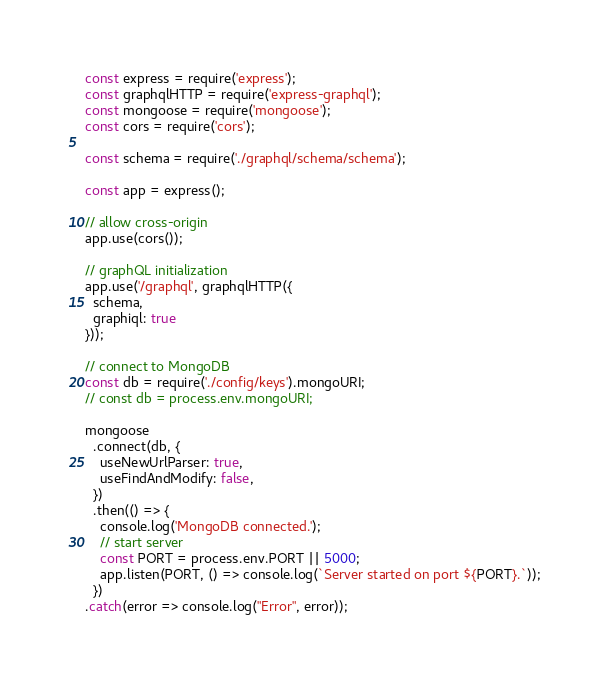<code> <loc_0><loc_0><loc_500><loc_500><_JavaScript_>const express = require('express');
const graphqlHTTP = require('express-graphql');
const mongoose = require('mongoose');
const cors = require('cors');

const schema = require('./graphql/schema/schema');

const app = express();

// allow cross-origin
app.use(cors());

// graphQL initialization
app.use('/graphql', graphqlHTTP({
  schema,
  graphiql: true
}));

// connect to MongoDB
const db = require('./config/keys').mongoURI;
// const db = process.env.mongoURI;

mongoose
  .connect(db, {
    useNewUrlParser: true,
    useFindAndModify: false,
  })
  .then(() => {
    console.log('MongoDB connected.');
    // start server
    const PORT = process.env.PORT || 5000;
    app.listen(PORT, () => console.log(`Server started on port ${PORT}.`));
  })
.catch(error => console.log("Error", error));
</code> 